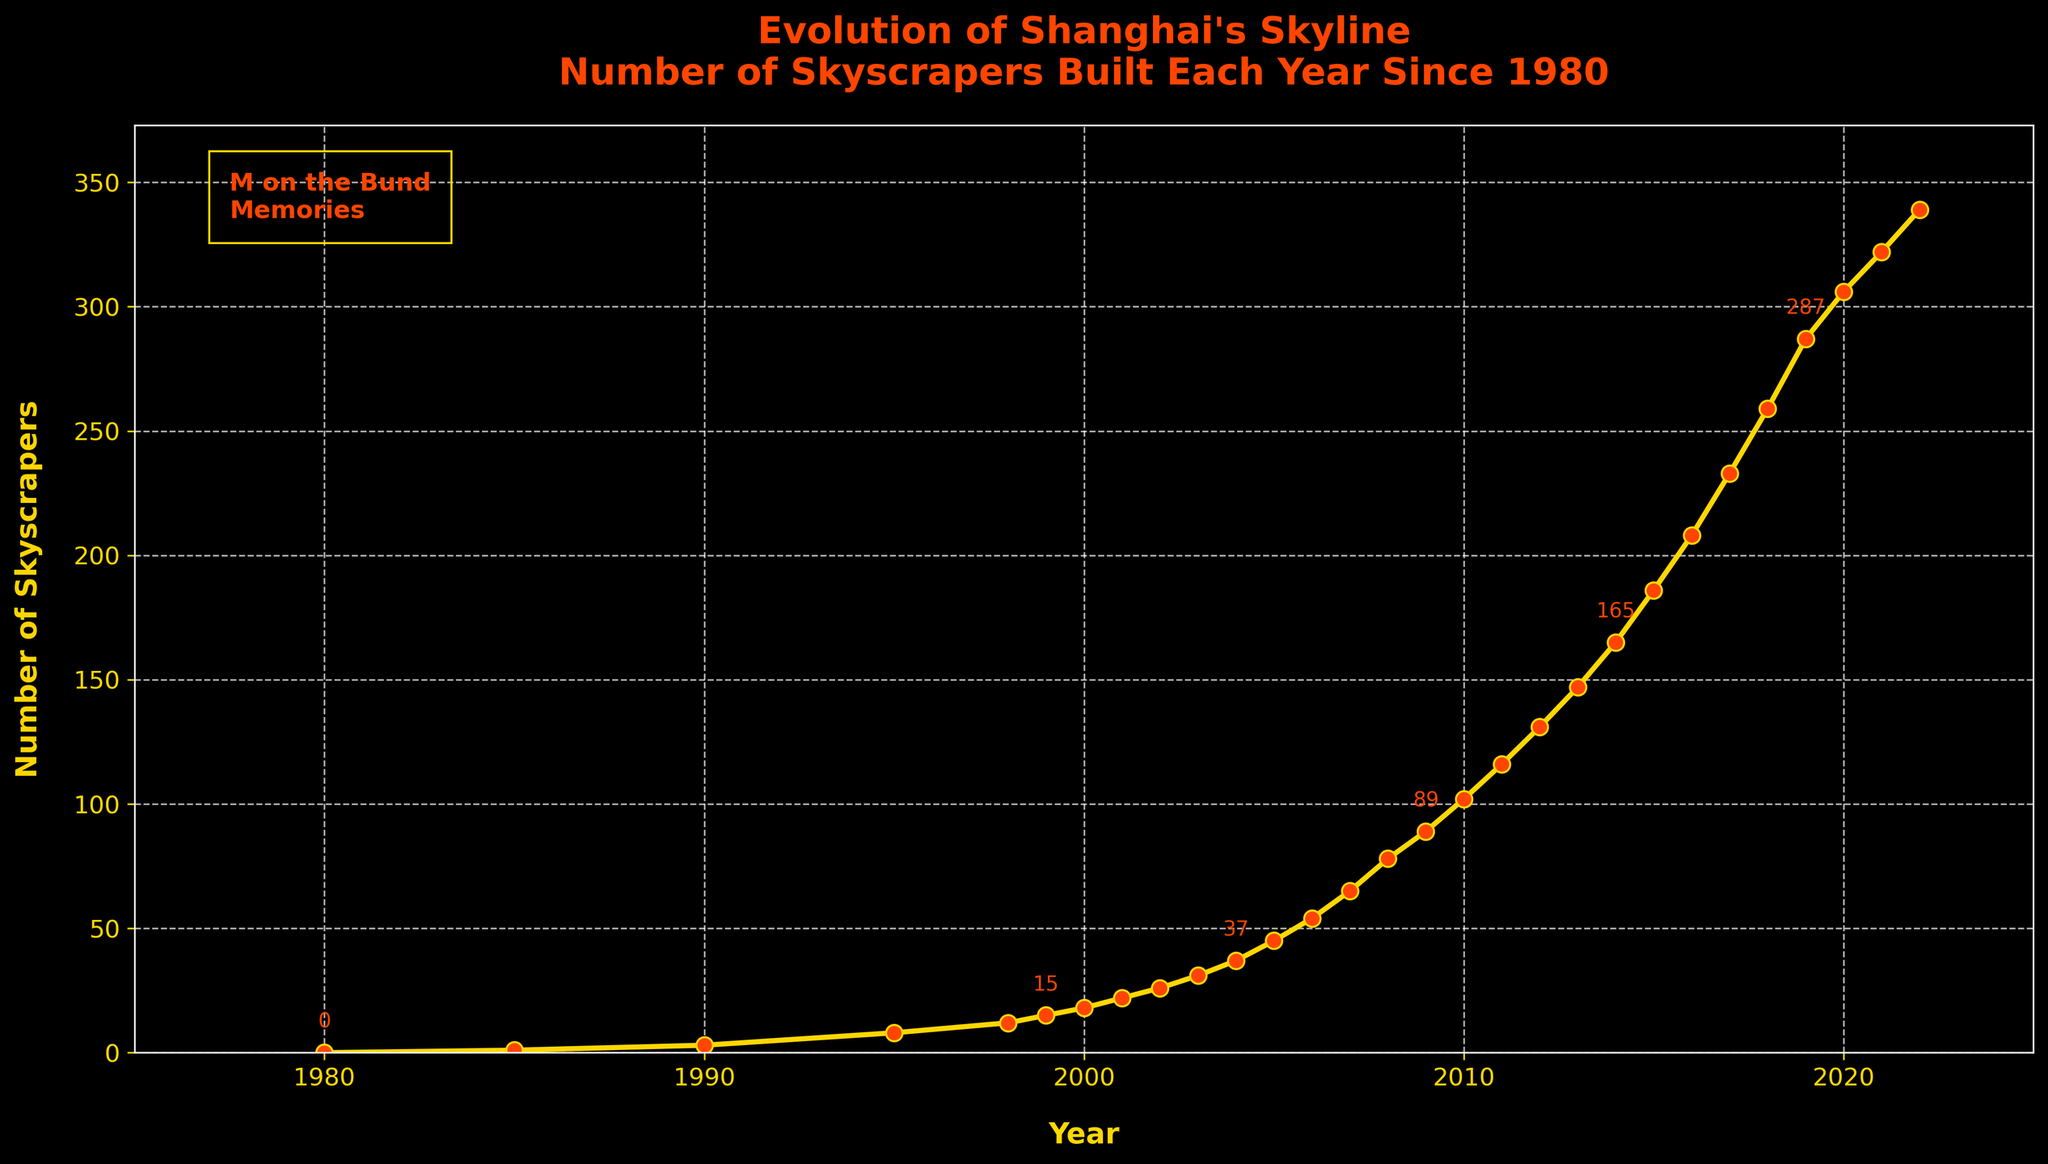When did the number of skyscrapers in Shanghai first exceed 100? Looking at the plot, we see that between 2009 and 2010, the number of skyscrapers surpassed 100. Specifically, in 2010, the number reached 102.
Answer: 2010 How many skyscrapers were built between 1995 and 2005? To find this, we look at the number of skyscrapers in 2005 (45) and subtract the number in 1995 (8), then subtract the initial value from the latter: 45 - 8 = 37.
Answer: 37 What is the increase in the number of skyscrapers from 2010 to 2020? The number of skyscrapers in 2010 is 102 and in 2020 it is 306. Subtracting the 2010 value from the 2020 value gives us: 306 - 102 = 204.
Answer: 204 Between 1980 and 2022, in which year was the highest number of skyscrapers built? Observing the slope of the line, the steepest segment from 2018 to 2019 shows the largest increase. Thus, 2019 saw the highest number of skyscrapers built.
Answer: 2019 Compare the number of skyscrapers built in 2005 to those built in 1995. According to the figure, 45 skyscrapers were built by 2005 and 8 by 1995. Thus, 2005 had significantly more (45 - 8 = 37 more) than 1995.
Answer: 2005 How many skyscrapers were built in the five years between 2010 and 2015? Number in 2015 is 186, and in 2010 it is 102. Subtract: 186 - 102 = 84.
Answer: 84 Which decade showed the most rapid growth in skyscraper construction? The line's steepest section is from 2010 to 2020, highlighting this decade's rapid growth.
Answer: 2010-2020 What is the yearly average increase in skyscrapers from 2000 to 2005? The number in 2000 is 18, and in 2005 it is 45. Over 5 years: (45 - 18) / 5 = 5.4 per year.
Answer: 5.4 per year What does the yellow line color indicate in this plot? The color emphasizes the number of skyscrapers, with its brightness making data points easily distinguishable against the dark background.
Answer: Number of skyscrapers 